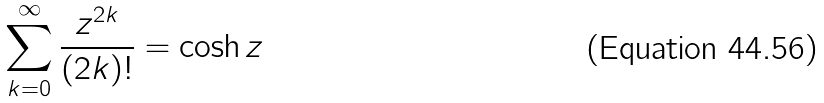Convert formula to latex. <formula><loc_0><loc_0><loc_500><loc_500>\sum _ { k = 0 } ^ { \infty } \frac { z ^ { 2 k } } { ( 2 k ) ! } = \cosh z</formula> 